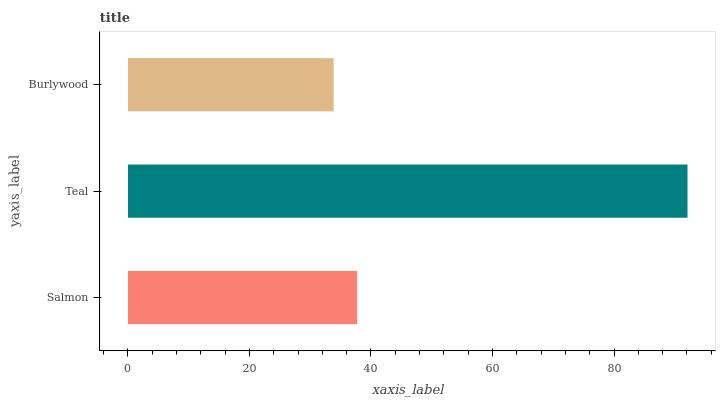Is Burlywood the minimum?
Answer yes or no. Yes. Is Teal the maximum?
Answer yes or no. Yes. Is Teal the minimum?
Answer yes or no. No. Is Burlywood the maximum?
Answer yes or no. No. Is Teal greater than Burlywood?
Answer yes or no. Yes. Is Burlywood less than Teal?
Answer yes or no. Yes. Is Burlywood greater than Teal?
Answer yes or no. No. Is Teal less than Burlywood?
Answer yes or no. No. Is Salmon the high median?
Answer yes or no. Yes. Is Salmon the low median?
Answer yes or no. Yes. Is Burlywood the high median?
Answer yes or no. No. Is Burlywood the low median?
Answer yes or no. No. 